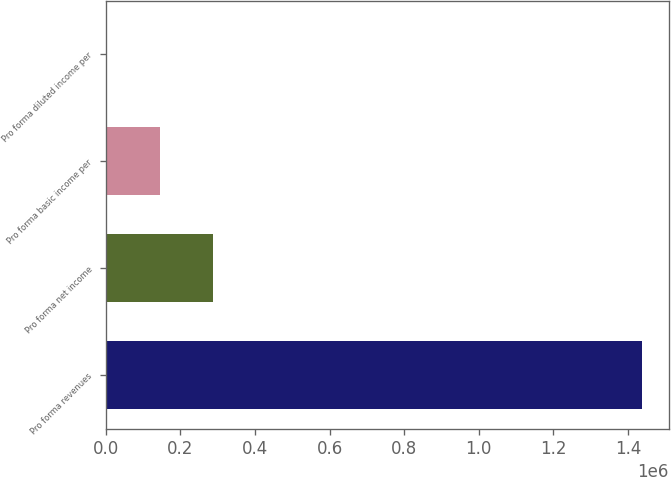<chart> <loc_0><loc_0><loc_500><loc_500><bar_chart><fcel>Pro forma revenues<fcel>Pro forma net income<fcel>Pro forma basic income per<fcel>Pro forma diluted income per<nl><fcel>1.43758e+06<fcel>287517<fcel>143759<fcel>1.52<nl></chart> 